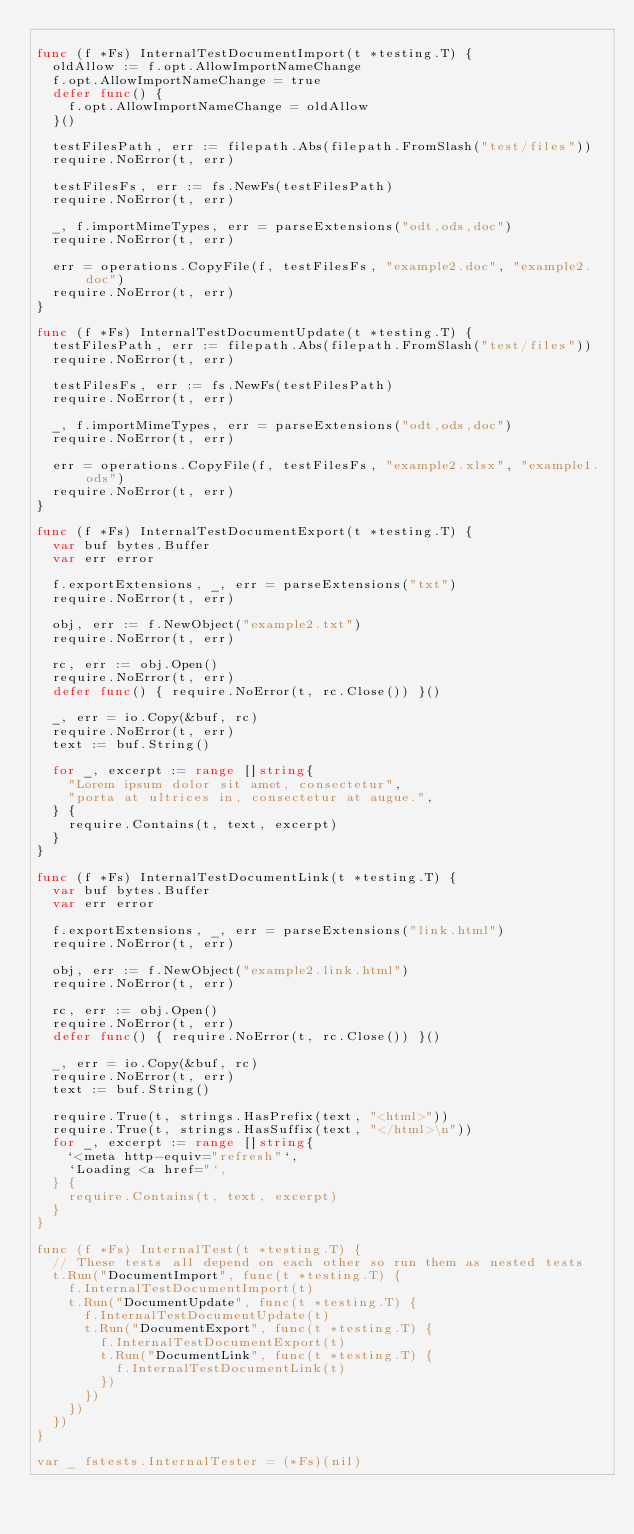Convert code to text. <code><loc_0><loc_0><loc_500><loc_500><_Go_>
func (f *Fs) InternalTestDocumentImport(t *testing.T) {
	oldAllow := f.opt.AllowImportNameChange
	f.opt.AllowImportNameChange = true
	defer func() {
		f.opt.AllowImportNameChange = oldAllow
	}()

	testFilesPath, err := filepath.Abs(filepath.FromSlash("test/files"))
	require.NoError(t, err)

	testFilesFs, err := fs.NewFs(testFilesPath)
	require.NoError(t, err)

	_, f.importMimeTypes, err = parseExtensions("odt,ods,doc")
	require.NoError(t, err)

	err = operations.CopyFile(f, testFilesFs, "example2.doc", "example2.doc")
	require.NoError(t, err)
}

func (f *Fs) InternalTestDocumentUpdate(t *testing.T) {
	testFilesPath, err := filepath.Abs(filepath.FromSlash("test/files"))
	require.NoError(t, err)

	testFilesFs, err := fs.NewFs(testFilesPath)
	require.NoError(t, err)

	_, f.importMimeTypes, err = parseExtensions("odt,ods,doc")
	require.NoError(t, err)

	err = operations.CopyFile(f, testFilesFs, "example2.xlsx", "example1.ods")
	require.NoError(t, err)
}

func (f *Fs) InternalTestDocumentExport(t *testing.T) {
	var buf bytes.Buffer
	var err error

	f.exportExtensions, _, err = parseExtensions("txt")
	require.NoError(t, err)

	obj, err := f.NewObject("example2.txt")
	require.NoError(t, err)

	rc, err := obj.Open()
	require.NoError(t, err)
	defer func() { require.NoError(t, rc.Close()) }()

	_, err = io.Copy(&buf, rc)
	require.NoError(t, err)
	text := buf.String()

	for _, excerpt := range []string{
		"Lorem ipsum dolor sit amet, consectetur",
		"porta at ultrices in, consectetur at augue.",
	} {
		require.Contains(t, text, excerpt)
	}
}

func (f *Fs) InternalTestDocumentLink(t *testing.T) {
	var buf bytes.Buffer
	var err error

	f.exportExtensions, _, err = parseExtensions("link.html")
	require.NoError(t, err)

	obj, err := f.NewObject("example2.link.html")
	require.NoError(t, err)

	rc, err := obj.Open()
	require.NoError(t, err)
	defer func() { require.NoError(t, rc.Close()) }()

	_, err = io.Copy(&buf, rc)
	require.NoError(t, err)
	text := buf.String()

	require.True(t, strings.HasPrefix(text, "<html>"))
	require.True(t, strings.HasSuffix(text, "</html>\n"))
	for _, excerpt := range []string{
		`<meta http-equiv="refresh"`,
		`Loading <a href="`,
	} {
		require.Contains(t, text, excerpt)
	}
}

func (f *Fs) InternalTest(t *testing.T) {
	// These tests all depend on each other so run them as nested tests
	t.Run("DocumentImport", func(t *testing.T) {
		f.InternalTestDocumentImport(t)
		t.Run("DocumentUpdate", func(t *testing.T) {
			f.InternalTestDocumentUpdate(t)
			t.Run("DocumentExport", func(t *testing.T) {
				f.InternalTestDocumentExport(t)
				t.Run("DocumentLink", func(t *testing.T) {
					f.InternalTestDocumentLink(t)
				})
			})
		})
	})
}

var _ fstests.InternalTester = (*Fs)(nil)
</code> 